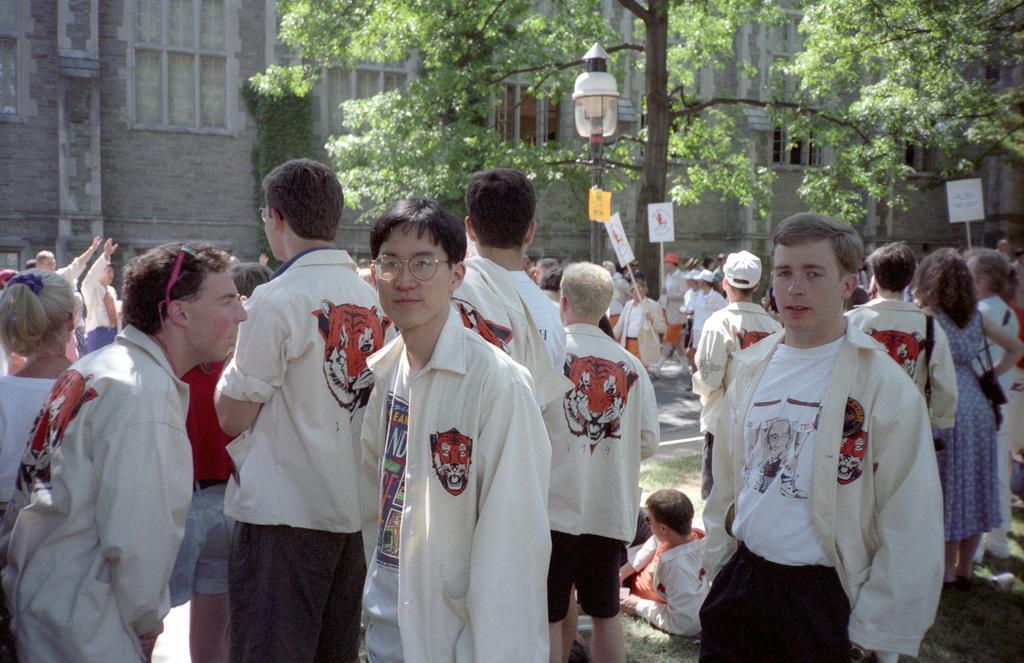Please provide a concise description of this image. In this image I can see number of people are standing and I can see most of them are wearing white colour jackets. In the background I can see few trees, few boards, a light, a building, number of windows and on these boards I can see something is written. In the front I can see a man is wearing specs. 